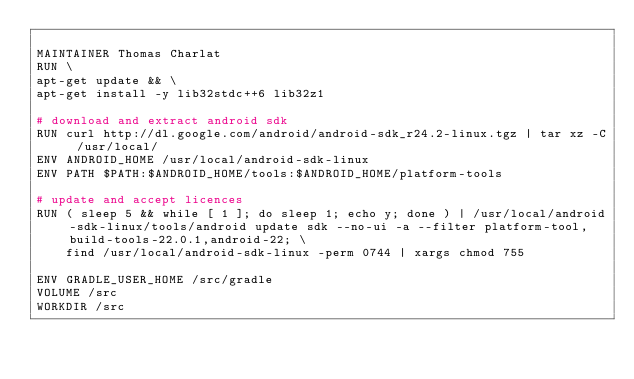Convert code to text. <code><loc_0><loc_0><loc_500><loc_500><_Dockerfile_>
MAINTAINER Thomas Charlat
RUN \
apt-get update && \
apt-get install -y lib32stdc++6 lib32z1

# download and extract android sdk
RUN curl http://dl.google.com/android/android-sdk_r24.2-linux.tgz | tar xz -C /usr/local/
ENV ANDROID_HOME /usr/local/android-sdk-linux
ENV PATH $PATH:$ANDROID_HOME/tools:$ANDROID_HOME/platform-tools

# update and accept licences
RUN ( sleep 5 && while [ 1 ]; do sleep 1; echo y; done ) | /usr/local/android-sdk-linux/tools/android update sdk --no-ui -a --filter platform-tool,build-tools-22.0.1,android-22; \
    find /usr/local/android-sdk-linux -perm 0744 | xargs chmod 755

ENV GRADLE_USER_HOME /src/gradle
VOLUME /src
WORKDIR /src
</code> 